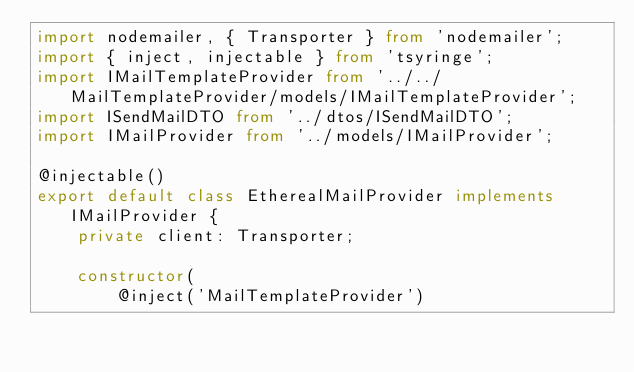Convert code to text. <code><loc_0><loc_0><loc_500><loc_500><_TypeScript_>import nodemailer, { Transporter } from 'nodemailer';
import { inject, injectable } from 'tsyringe';
import IMailTemplateProvider from '../../MailTemplateProvider/models/IMailTemplateProvider';
import ISendMailDTO from '../dtos/ISendMailDTO';
import IMailProvider from '../models/IMailProvider';

@injectable()
export default class EtherealMailProvider implements IMailProvider {
    private client: Transporter;

    constructor(
        @inject('MailTemplateProvider')</code> 